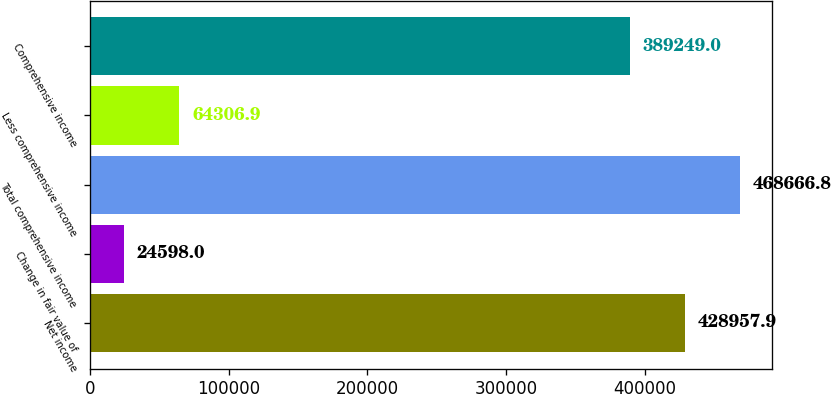Convert chart to OTSL. <chart><loc_0><loc_0><loc_500><loc_500><bar_chart><fcel>Net income<fcel>Change in fair value of<fcel>Total comprehensive income<fcel>Less comprehensive income<fcel>Comprehensive income<nl><fcel>428958<fcel>24598<fcel>468667<fcel>64306.9<fcel>389249<nl></chart> 